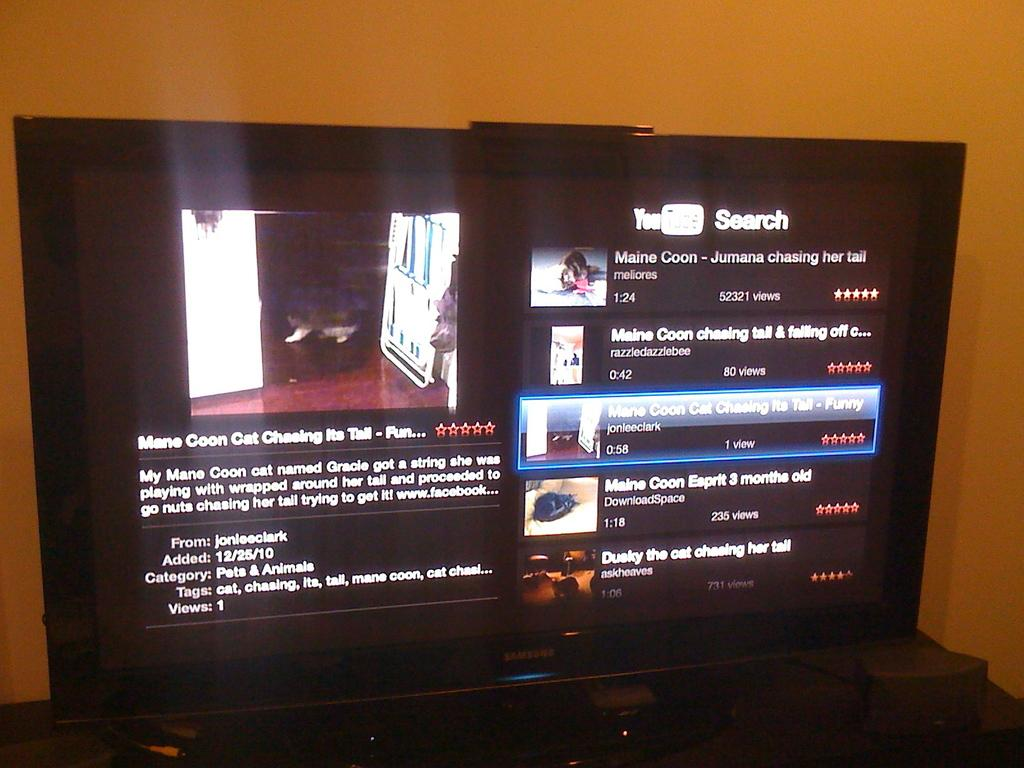<image>
Describe the image concisely. Television screen which says "My Mane Coon" as the first sentence. 